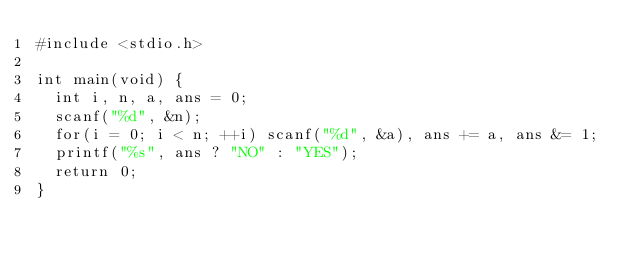Convert code to text. <code><loc_0><loc_0><loc_500><loc_500><_C++_>#include <stdio.h>

int main(void) {
  int i, n, a, ans = 0;
  scanf("%d", &n);
  for(i = 0; i < n; ++i) scanf("%d", &a), ans += a, ans &= 1;
  printf("%s", ans ? "NO" : "YES");
  return 0;
}</code> 